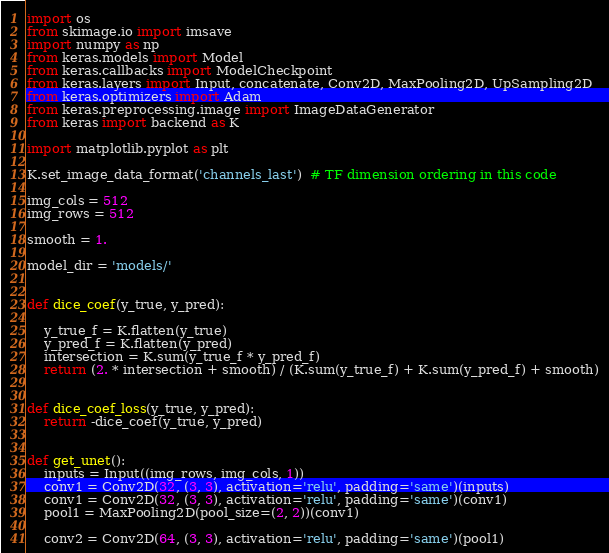Convert code to text. <code><loc_0><loc_0><loc_500><loc_500><_Python_>
import os
from skimage.io import imsave
import numpy as np
from keras.models import Model
from keras.callbacks import ModelCheckpoint
from keras.layers import Input, concatenate, Conv2D, MaxPooling2D, UpSampling2D
from keras.optimizers import Adam
from keras.preprocessing.image import ImageDataGenerator
from keras import backend as K

import matplotlib.pyplot as plt

K.set_image_data_format('channels_last')  # TF dimension ordering in this code

img_cols = 512
img_rows = 512

smooth = 1.

model_dir = 'models/'


def dice_coef(y_true, y_pred):

    y_true_f = K.flatten(y_true)
    y_pred_f = K.flatten(y_pred)
    intersection = K.sum(y_true_f * y_pred_f)
    return (2. * intersection + smooth) / (K.sum(y_true_f) + K.sum(y_pred_f) + smooth)


def dice_coef_loss(y_true, y_pred):
    return -dice_coef(y_true, y_pred)


def get_unet():
    inputs = Input((img_rows, img_cols, 1))
    conv1 = Conv2D(32, (3, 3), activation='relu', padding='same')(inputs)
    conv1 = Conv2D(32, (3, 3), activation='relu', padding='same')(conv1)
    pool1 = MaxPooling2D(pool_size=(2, 2))(conv1)

    conv2 = Conv2D(64, (3, 3), activation='relu', padding='same')(pool1)</code> 